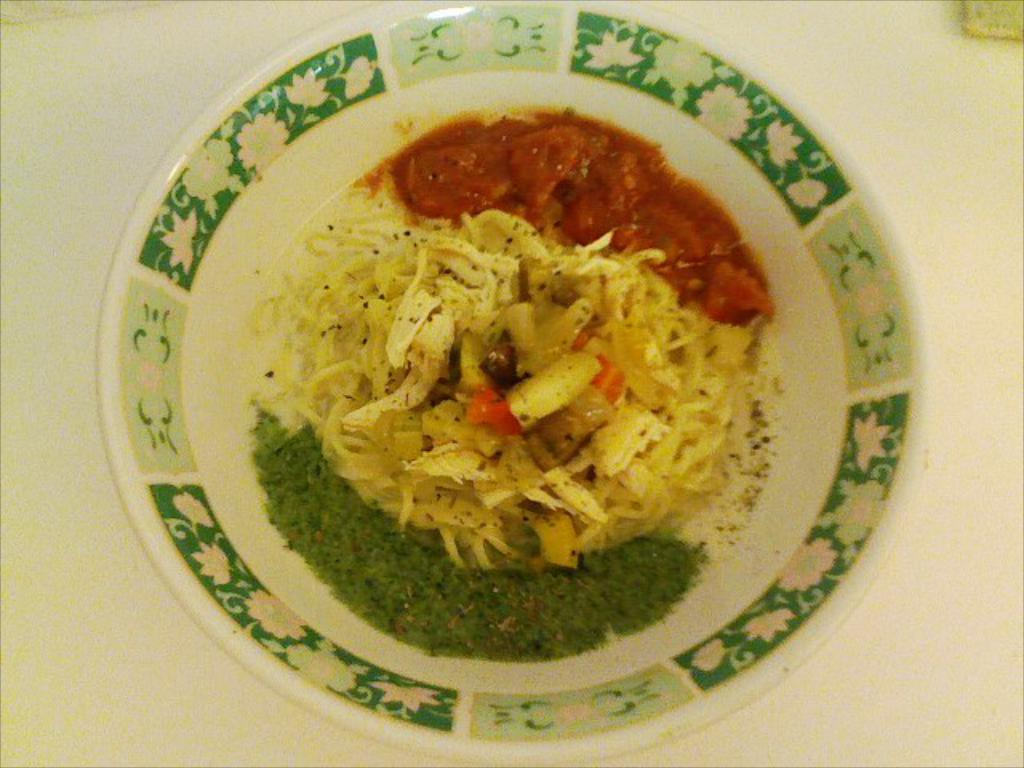What is the main object in the image? There is a dish in the image. How is the dish positioned in the image? The dish is on a plate. Where is the plate located in the image? The plate is placed on a table. How many tomatoes are on the range in the image? There are no tomatoes or ranges present in the image; it only features a dish on a plate placed on a table. 